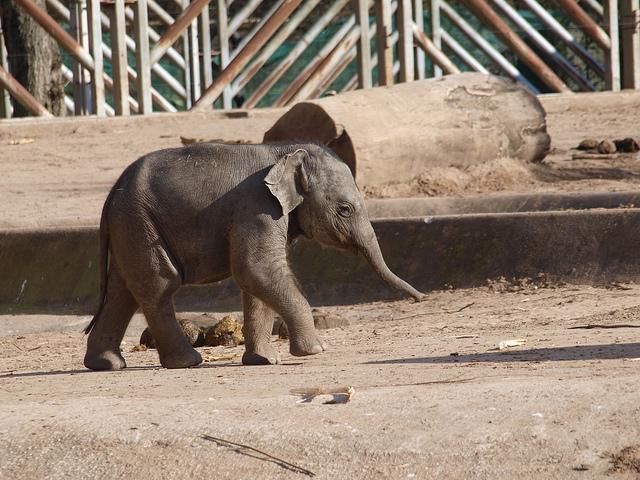How old is the elephant?
Keep it brief. Young. Is the elephant in a fenced in location?
Short answer required. Yes. Is the elephant likely in captivity?
Quick response, please. Yes. 